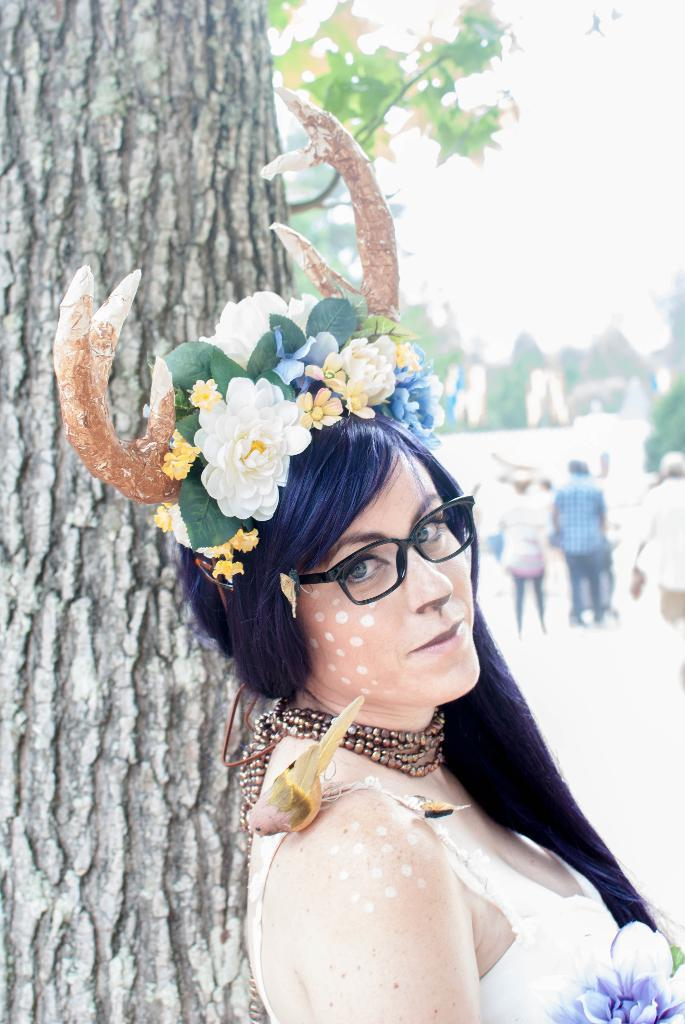Who is the main subject in the image? There is a woman in the image. What is the woman holding in the image? The woman has flowers. What unique feature does the woman have? The woman has horns. What can be seen on the left side of the image? There is a tree on the left side of the image. What is visible in the background of the image? There are trees visible in the background of the image. What is visible at the top of the image? The sky is visible at the top of the image. How many flies can be seen buzzing around the woman's head in the image? There are no flies visible in the image. What type of baby is sitting on the woman's lap in the image? There is no baby present in the image; the woman is holding flowers and has horns. 